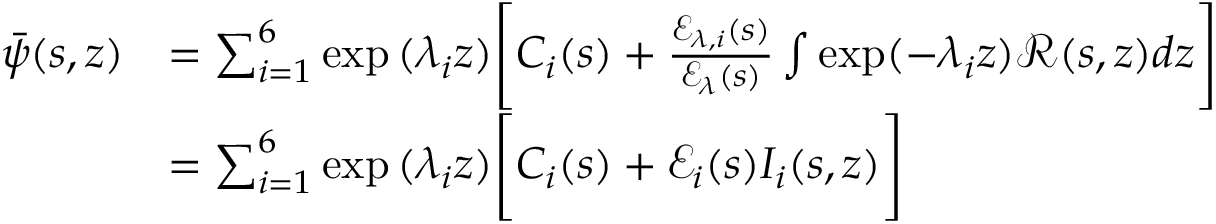Convert formula to latex. <formula><loc_0><loc_0><loc_500><loc_500>\begin{array} { r l } { \bar { \psi } ( s , z ) } & { = \sum _ { i = 1 } ^ { 6 } \exp { ( \lambda _ { i } z ) } \left [ C _ { i } ( s ) + \frac { \ m a t h s c r { E } _ { \lambda , i } ( s ) } { \ m a t h s c r { E } _ { \lambda } ( s ) } \int \exp ( - \lambda _ { i } z ) \ m a t h s c r { R } ( s , z ) d z \right ] } \\ & { = \sum _ { i = 1 } ^ { 6 } \exp { ( \lambda _ { i } z ) } \left [ C _ { i } ( s ) + \ m a t h s c r { E } _ { i } ( s ) I _ { i } ( s , z ) \right ] } \end{array}</formula> 